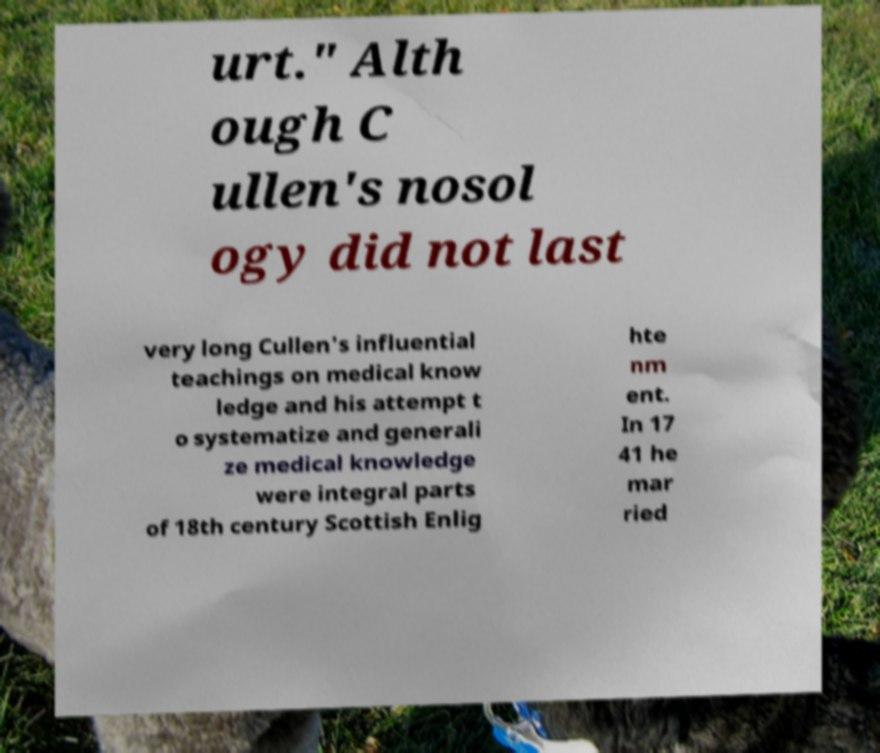Could you extract and type out the text from this image? urt." Alth ough C ullen's nosol ogy did not last very long Cullen's influential teachings on medical know ledge and his attempt t o systematize and generali ze medical knowledge were integral parts of 18th century Scottish Enlig hte nm ent. In 17 41 he mar ried 